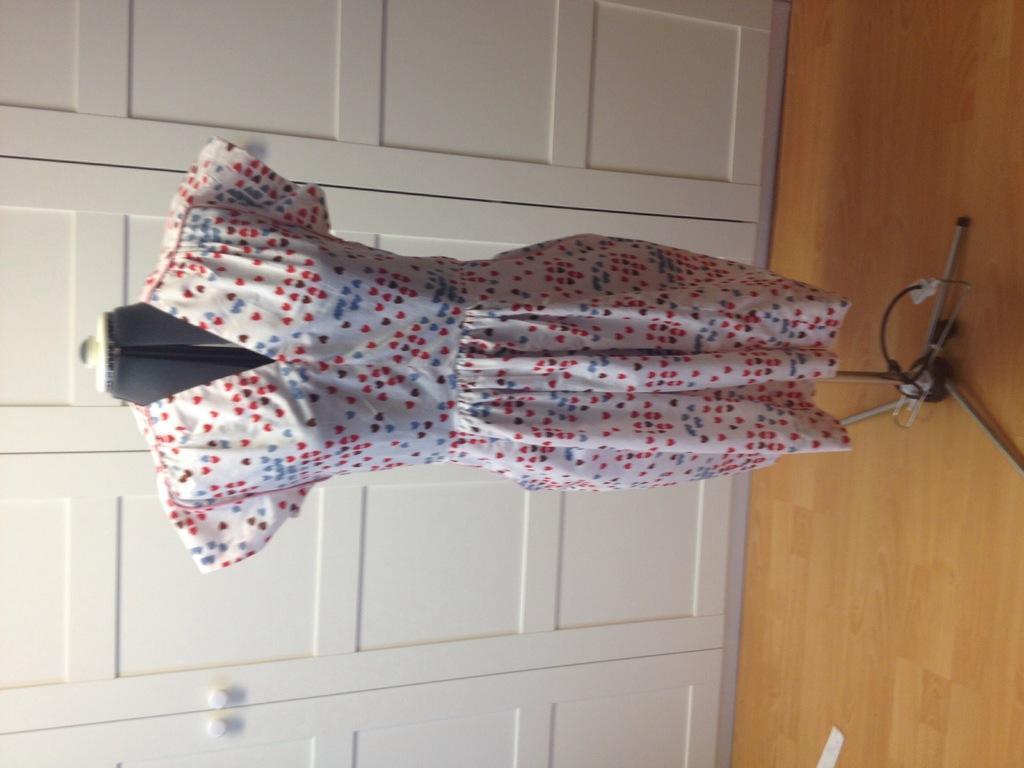How would you summarize this image in a sentence or two? In the center of the image there is a dress on the stand. In the background of the image there are doors. At the bottom of the image there is wooden flooring. 